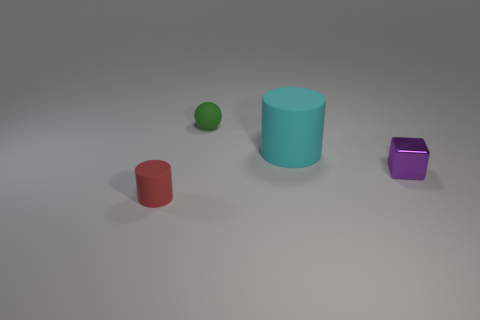There is a metal block; does it have the same color as the tiny rubber thing in front of the cyan thing?
Your answer should be very brief. No. Is the number of large gray matte cubes less than the number of big cyan rubber things?
Keep it short and to the point. Yes. Is the number of big rubber objects in front of the small rubber sphere greater than the number of tiny matte spheres to the right of the purple block?
Your answer should be compact. Yes. Is the material of the cube the same as the small red object?
Give a very brief answer. No. There is a matte cylinder on the left side of the cyan object; what number of small matte objects are to the right of it?
Provide a succinct answer. 1. There is a thing that is in front of the purple metal thing; is its color the same as the block?
Your answer should be very brief. No. What number of objects are red things or rubber objects that are behind the big cyan rubber object?
Your response must be concise. 2. There is a tiny matte thing behind the tiny red rubber thing; is its shape the same as the small thing that is right of the cyan thing?
Your answer should be compact. No. Is there any other thing that is the same color as the sphere?
Offer a terse response. No. There is a tiny object that is the same material as the tiny green ball; what shape is it?
Offer a terse response. Cylinder. 